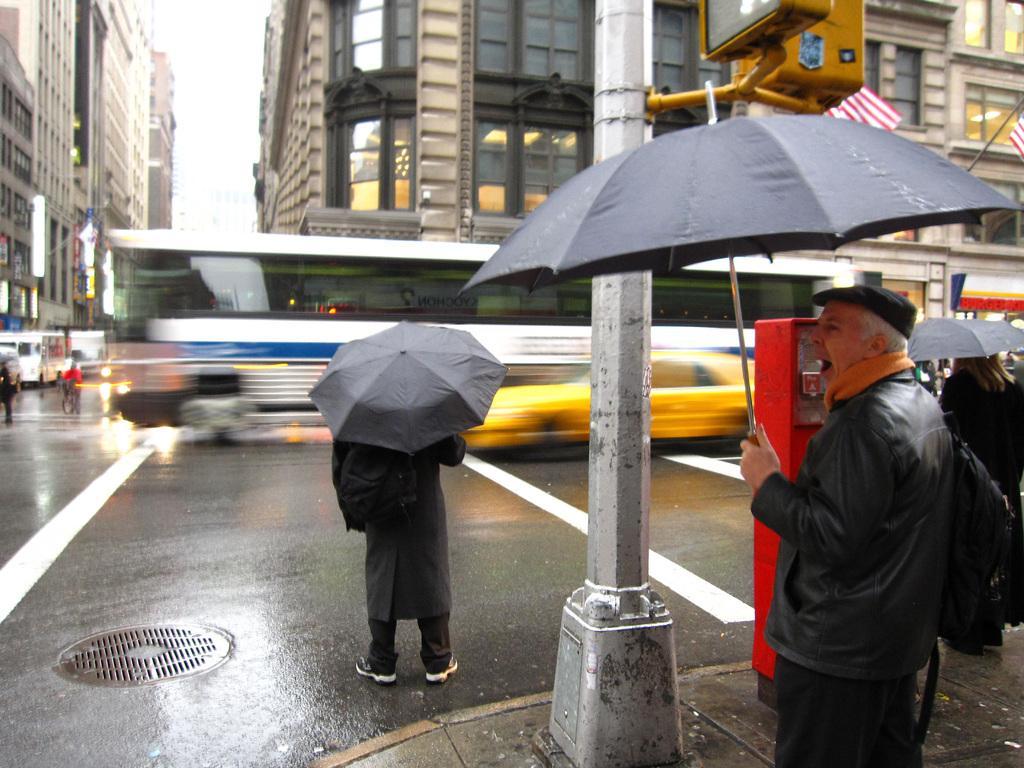Can you describe this image briefly? In this image we can see people standing on the road and some of them are holding umbrellas in their hands, motor vehicles, electric lights, advertisements, buildings, flags to the flag posts and sky. 